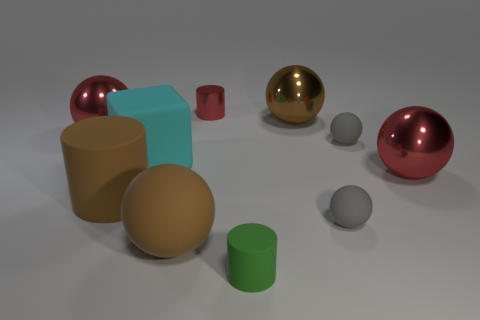Subtract all red cylinders. How many cylinders are left? 2 Add 8 tiny metallic cylinders. How many tiny metallic cylinders exist? 9 Subtract all red spheres. How many spheres are left? 4 Subtract 1 brown cylinders. How many objects are left? 9 Subtract all cylinders. How many objects are left? 7 Subtract 1 cylinders. How many cylinders are left? 2 Subtract all brown spheres. Subtract all brown cubes. How many spheres are left? 4 Subtract all red balls. How many red cylinders are left? 1 Subtract all small red objects. Subtract all balls. How many objects are left? 3 Add 7 small green rubber objects. How many small green rubber objects are left? 8 